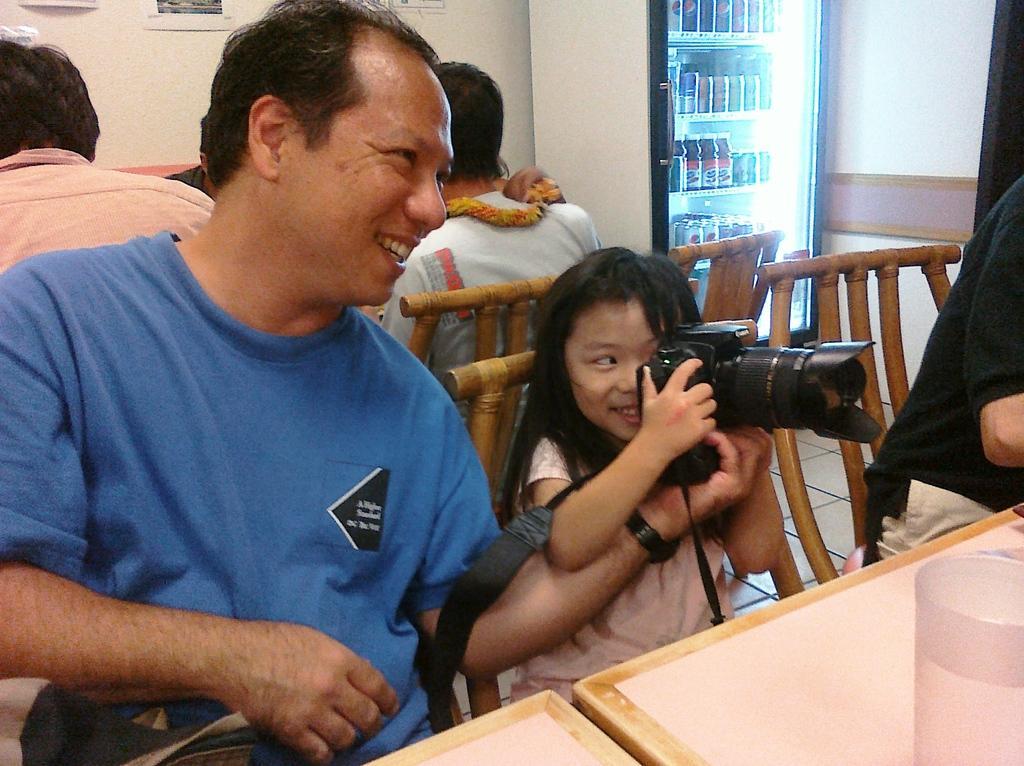Describe this image in one or two sentences. 3 people are sitting on the wooden chairs. the person at the left is wearing a blue t shirt. the person right to him is holding a camera in her hand. right to her a person is sitting wearing a black t shirt. in front of them there is a glass on the table. behind them there are other people sitting. at the back there is a white wall. at the right corner there is a white refrigerator inside which there are bottles and tins. 